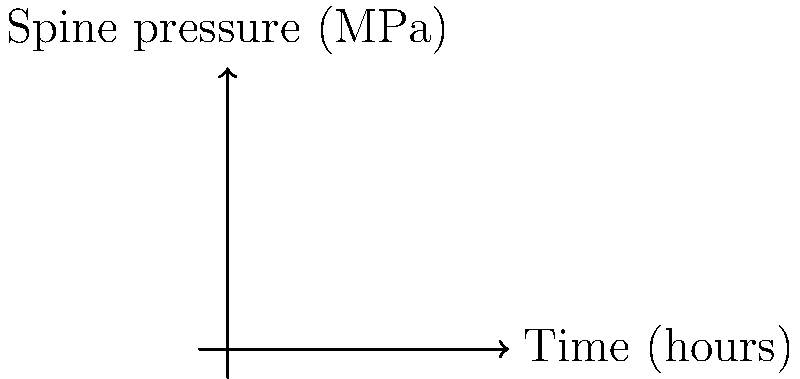As an ombudsman investigating the impact of prolonged sitting on media professionals, you come across a study on spinal pressure during extended computer use. The graph shows the relationship between time spent sitting at a computer and the pressure on the spine. Based on this data, what is the rate of increase in spine pressure (in MPa/hour) during the first hour of sitting? To calculate the rate of increase in spine pressure during the first hour, we need to follow these steps:

1. Identify the initial pressure (at t = 0 hours):
   $P_0 = 0.5$ MPa

2. Identify the pressure after one hour (at t = 1 hour):
   $P_1 = 1.2$ MPa

3. Calculate the change in pressure:
   $\Delta P = P_1 - P_0 = 1.2 - 0.5 = 0.7$ MPa

4. Calculate the rate of increase:
   Rate = $\frac{\text{Change in pressure}}{\text{Change in time}} = \frac{\Delta P}{\Delta t}$
   
   $\text{Rate} = \frac{0.7 \text{ MPa}}{1 \text{ hour}} = 0.7 \text{ MPa/hour}$

Therefore, the rate of increase in spine pressure during the first hour of sitting is 0.7 MPa/hour.
Answer: 0.7 MPa/hour 